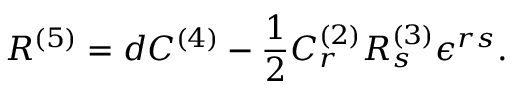Convert formula to latex. <formula><loc_0><loc_0><loc_500><loc_500>R ^ { ( 5 ) } = d C ^ { ( 4 ) } - \frac { 1 } { 2 } C _ { r } ^ { ( 2 ) } R _ { s } ^ { ( 3 ) } \epsilon ^ { r s } .</formula> 